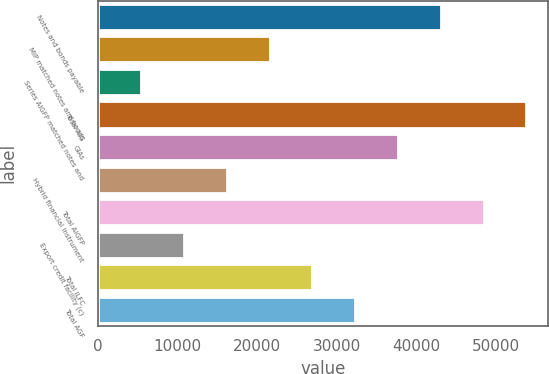Convert chart to OTSL. <chart><loc_0><loc_0><loc_500><loc_500><bar_chart><fcel>Notes and bonds payable<fcel>MIP matched notes and bonds<fcel>Series AIGFP matched notes and<fcel>Total AIG<fcel>GIAs<fcel>Hybrid financial instrument<fcel>Total AIGFP<fcel>Export credit facility (c)<fcel>Total ILFC<fcel>Total AGF<nl><fcel>43074.8<fcel>21564.4<fcel>5431.6<fcel>53830<fcel>37697.2<fcel>16186.8<fcel>48452.4<fcel>10809.2<fcel>26942<fcel>32319.6<nl></chart> 